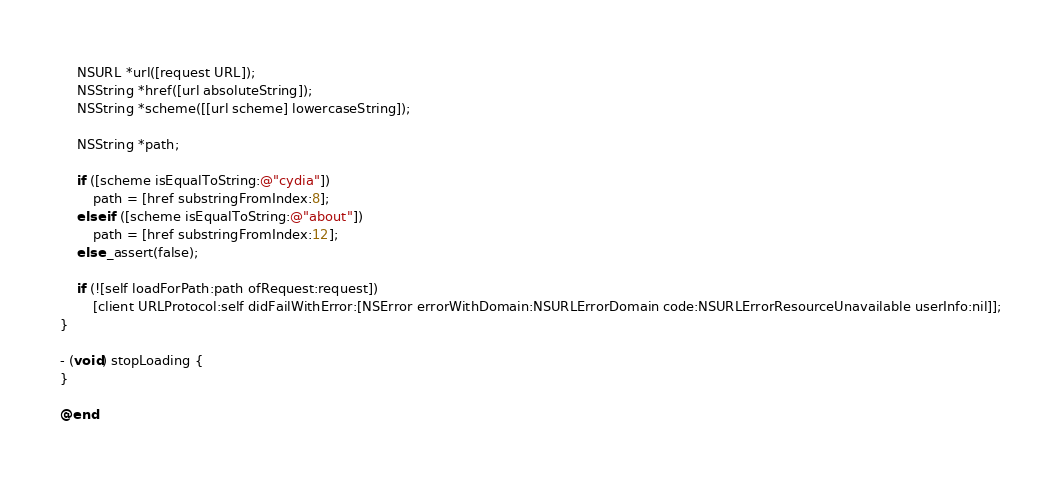<code> <loc_0><loc_0><loc_500><loc_500><_ObjectiveC_>
    NSURL *url([request URL]);
    NSString *href([url absoluteString]);
    NSString *scheme([[url scheme] lowercaseString]);

    NSString *path;

    if ([scheme isEqualToString:@"cydia"])
        path = [href substringFromIndex:8];
    else if ([scheme isEqualToString:@"about"])
        path = [href substringFromIndex:12];
    else _assert(false);

    if (![self loadForPath:path ofRequest:request])
        [client URLProtocol:self didFailWithError:[NSError errorWithDomain:NSURLErrorDomain code:NSURLErrorResourceUnavailable userInfo:nil]];
}

- (void) stopLoading {
}

@end
</code> 